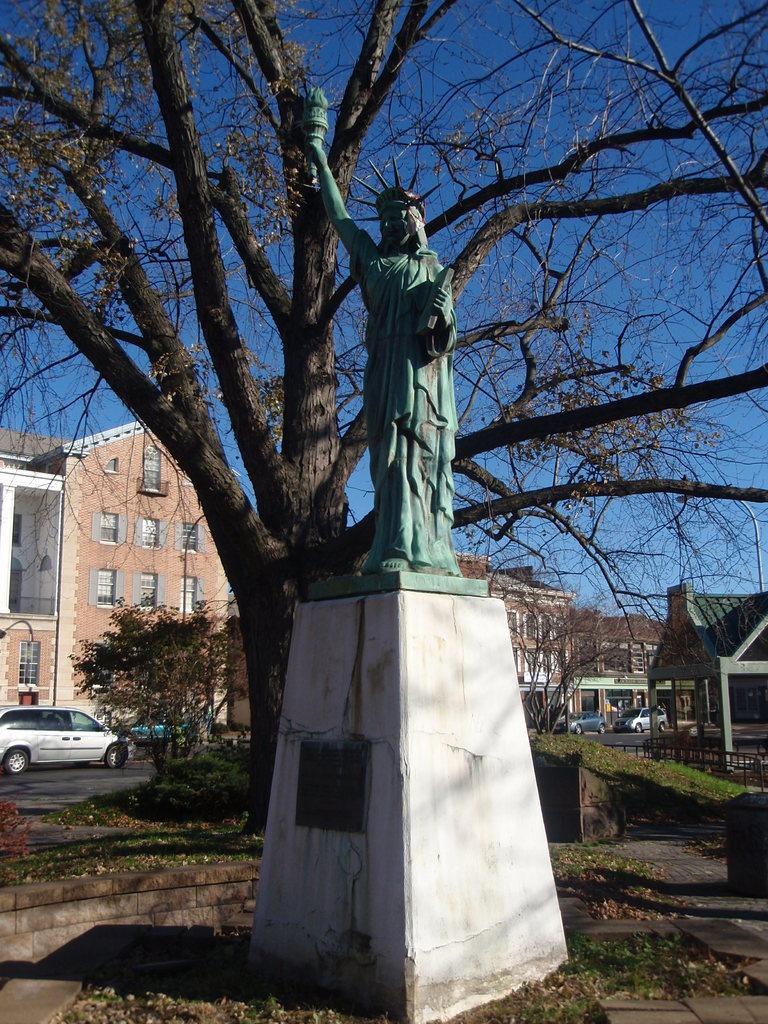In one or two sentences, can you explain what this image depicts? This picture shows a statue and we see trees and buildings and few cars and a blue sky. 